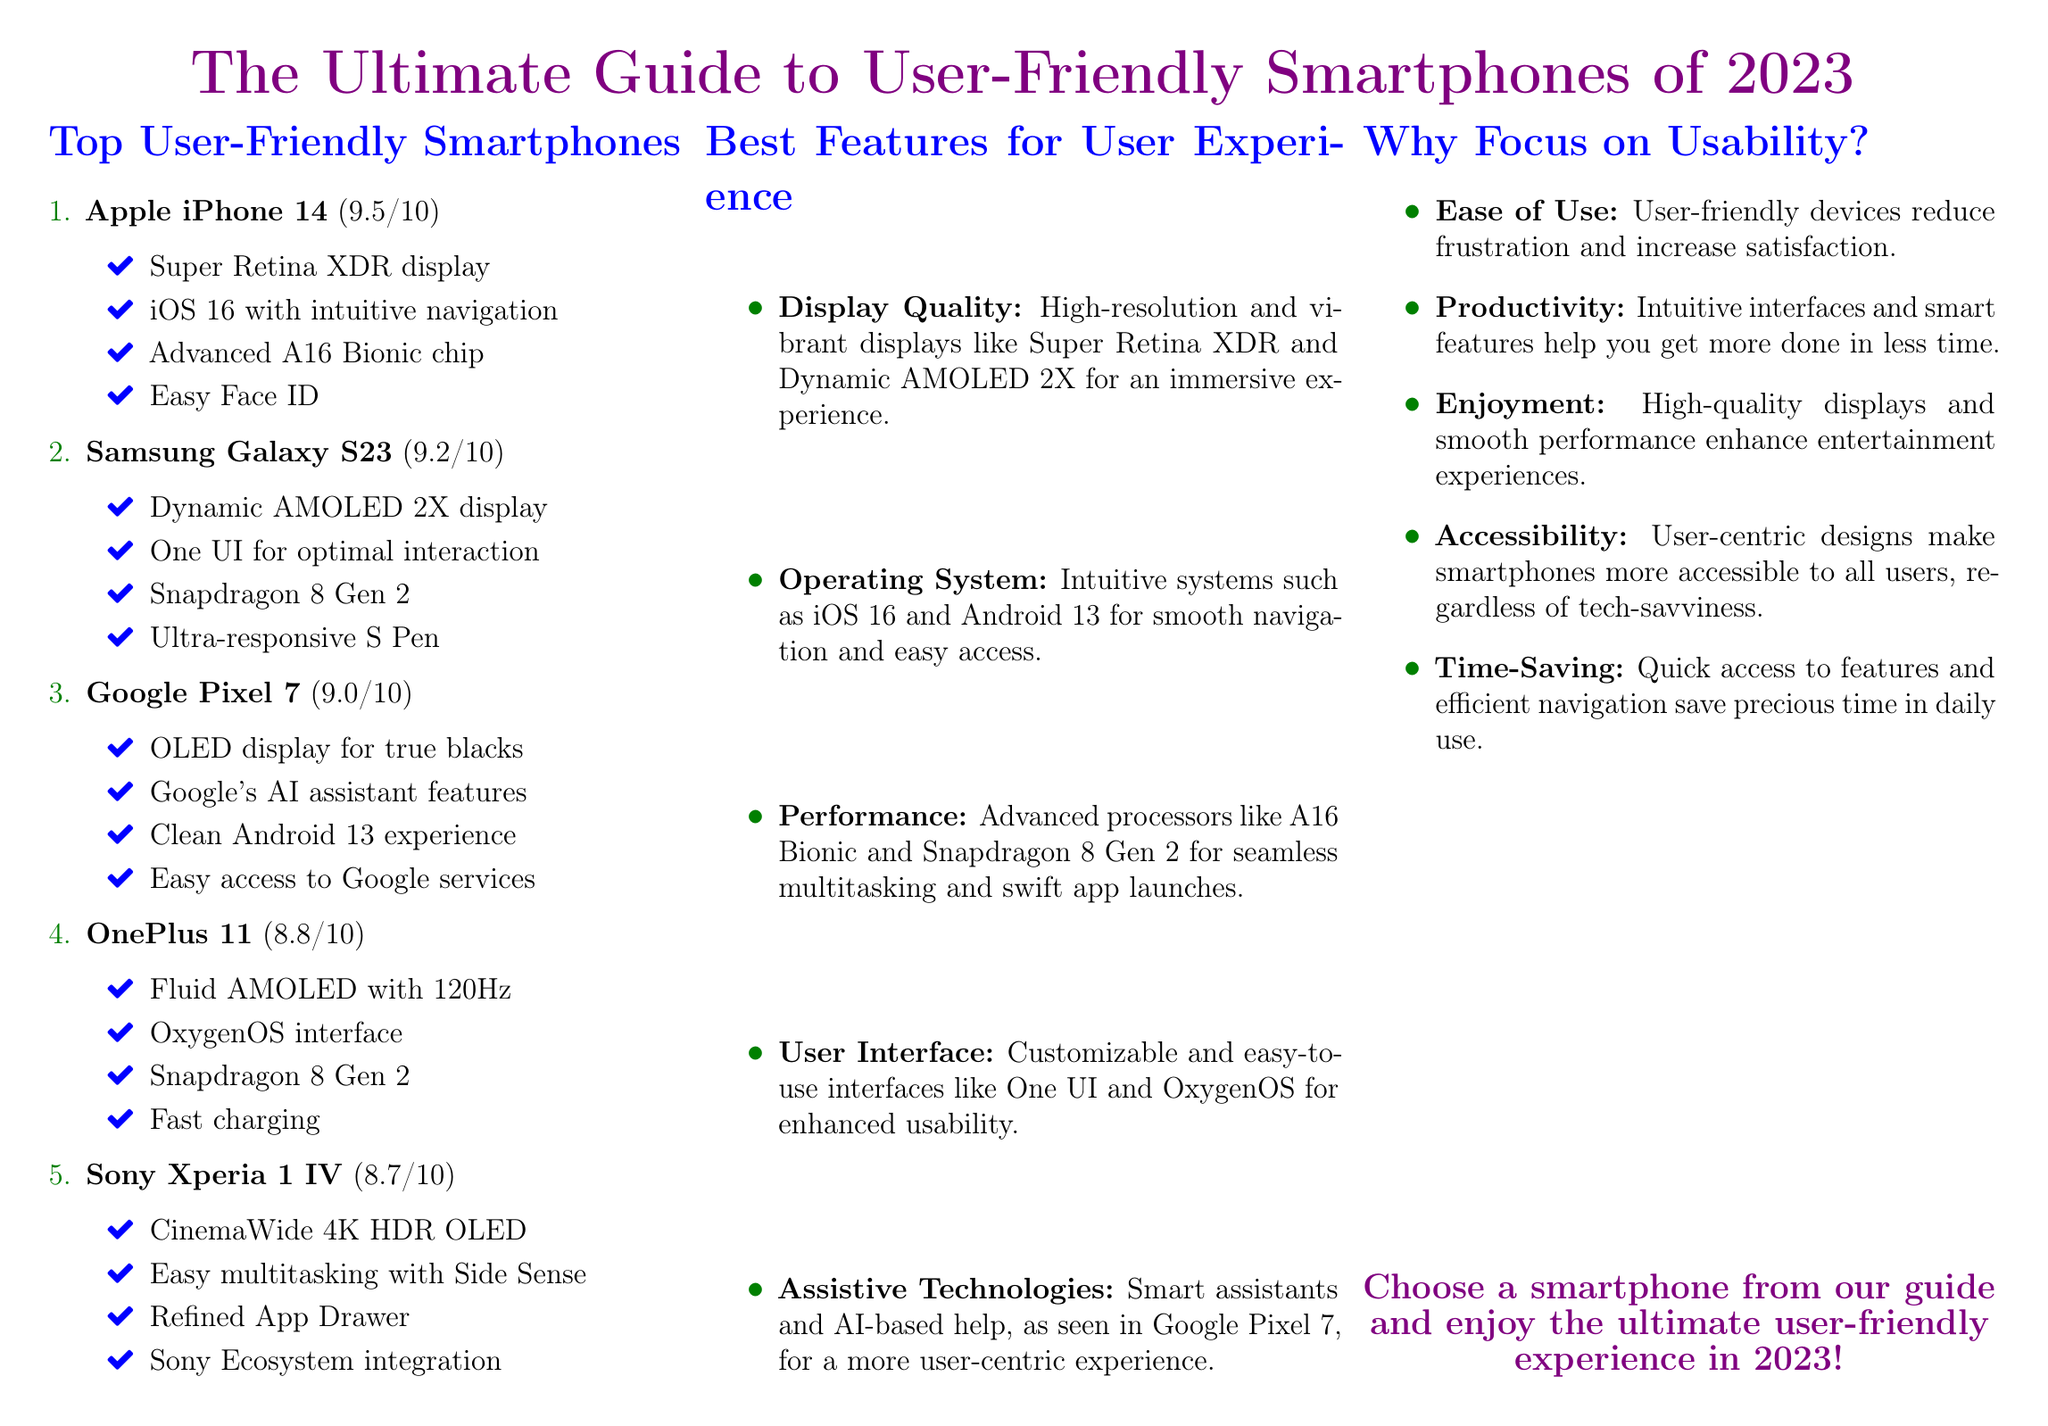What is the highest rating smartphone in the guide? The highest rating smartphone in the guide is the Apple iPhone 14 with a score of 9.5/10.
Answer: Apple iPhone 14 Which smartphone has a Dynamic AMOLED 2X display? The Samsung Galaxy S23 features a Dynamic AMOLED 2X display, as mentioned in the document.
Answer: Samsung Galaxy S23 What is the rating of the Google Pixel 7? The Google Pixel 7 has a rating of 9.0/10, which provides important information about its usability.
Answer: 9.0/10 What display technology is featured in the Sony Xperia 1 IV? The Sony Xperia 1 IV features a CinemaWide 4K HDR OLED display, showcasing its emphasis on visual quality.
Answer: CinemaWide 4K HDR OLED Which operating system does the Apple iPhone 14 use? The Apple iPhone 14 uses iOS 16, which is mentioned in the document as part of its usability features.
Answer: iOS 16 What type of processing chip does the OnePlus 11 use? The OnePlus 11 is equipped with the Snapdragon 8 Gen 2 chip, highlighting its performance capabilities.
Answer: Snapdragon 8 Gen 2 Why should we focus on usability according to the document? The document emphasizes that focusing on usability enhances enjoyment and accessibility among users.
Answer: Enjoyment What assists productivity in user-friendly smartphones? Intuitive interfaces and smart features assist productivity, as stated in the reasoning section of the document.
Answer: Intuitive interfaces How does the guide rate the Sony Xperia 1 IV? The Sony Xperia 1 IV is rated at 8.7/10, providing a comparative assessment among smartphones.
Answer: 8.7/10 